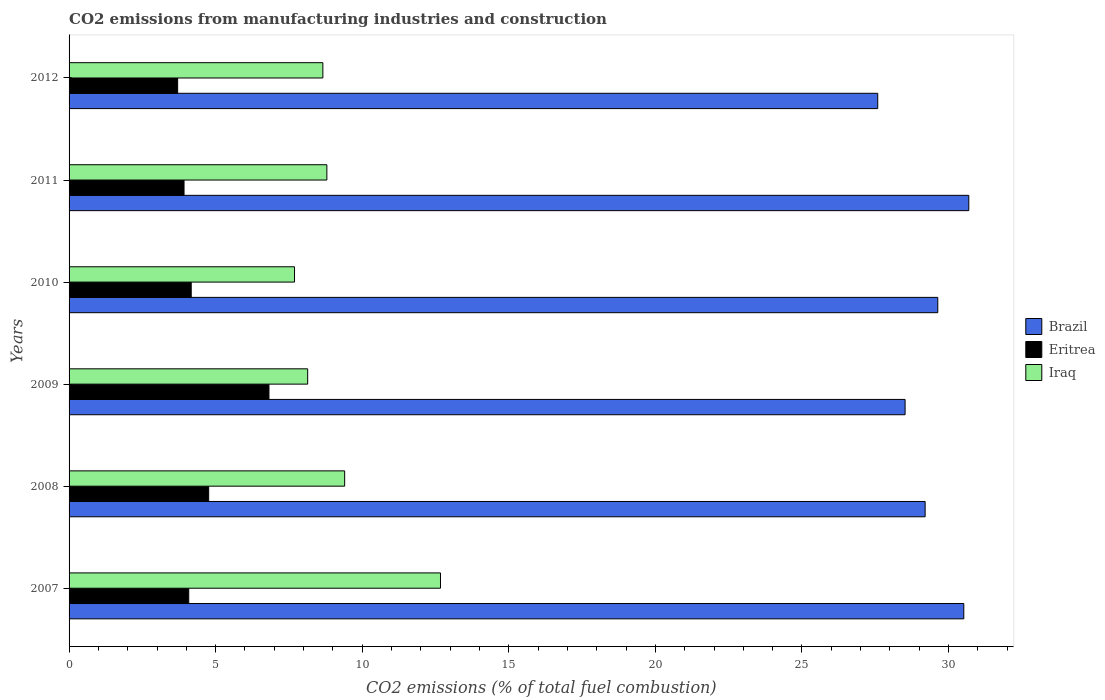Are the number of bars per tick equal to the number of legend labels?
Give a very brief answer. Yes. Are the number of bars on each tick of the Y-axis equal?
Offer a very short reply. Yes. How many bars are there on the 1st tick from the top?
Your answer should be very brief. 3. What is the label of the 2nd group of bars from the top?
Your response must be concise. 2011. In how many cases, is the number of bars for a given year not equal to the number of legend labels?
Your response must be concise. 0. What is the amount of CO2 emitted in Brazil in 2010?
Your response must be concise. 29.63. Across all years, what is the maximum amount of CO2 emitted in Brazil?
Offer a very short reply. 30.69. Across all years, what is the minimum amount of CO2 emitted in Brazil?
Give a very brief answer. 27.58. What is the total amount of CO2 emitted in Brazil in the graph?
Your answer should be compact. 176.15. What is the difference between the amount of CO2 emitted in Iraq in 2010 and that in 2012?
Offer a terse response. -0.97. What is the difference between the amount of CO2 emitted in Brazil in 2010 and the amount of CO2 emitted in Eritrea in 2008?
Provide a succinct answer. 24.87. What is the average amount of CO2 emitted in Eritrea per year?
Make the answer very short. 4.58. In the year 2008, what is the difference between the amount of CO2 emitted in Eritrea and amount of CO2 emitted in Iraq?
Provide a succinct answer. -4.64. What is the ratio of the amount of CO2 emitted in Brazil in 2007 to that in 2012?
Provide a short and direct response. 1.11. Is the amount of CO2 emitted in Eritrea in 2009 less than that in 2011?
Your answer should be compact. No. Is the difference between the amount of CO2 emitted in Eritrea in 2008 and 2012 greater than the difference between the amount of CO2 emitted in Iraq in 2008 and 2012?
Your answer should be compact. Yes. What is the difference between the highest and the second highest amount of CO2 emitted in Eritrea?
Provide a short and direct response. 2.06. What is the difference between the highest and the lowest amount of CO2 emitted in Eritrea?
Ensure brevity in your answer.  3.11. Is the sum of the amount of CO2 emitted in Brazil in 2011 and 2012 greater than the maximum amount of CO2 emitted in Iraq across all years?
Ensure brevity in your answer.  Yes. What does the 2nd bar from the top in 2007 represents?
Your answer should be very brief. Eritrea. What does the 2nd bar from the bottom in 2008 represents?
Offer a terse response. Eritrea. How many bars are there?
Give a very brief answer. 18. Are all the bars in the graph horizontal?
Offer a very short reply. Yes. How many years are there in the graph?
Offer a terse response. 6. What is the difference between two consecutive major ticks on the X-axis?
Give a very brief answer. 5. Does the graph contain any zero values?
Ensure brevity in your answer.  No. How many legend labels are there?
Offer a very short reply. 3. What is the title of the graph?
Offer a very short reply. CO2 emissions from manufacturing industries and construction. Does "Azerbaijan" appear as one of the legend labels in the graph?
Your answer should be compact. No. What is the label or title of the X-axis?
Make the answer very short. CO2 emissions (% of total fuel combustion). What is the CO2 emissions (% of total fuel combustion) in Brazil in 2007?
Your answer should be very brief. 30.52. What is the CO2 emissions (% of total fuel combustion) of Eritrea in 2007?
Your answer should be compact. 4.08. What is the CO2 emissions (% of total fuel combustion) of Iraq in 2007?
Give a very brief answer. 12.67. What is the CO2 emissions (% of total fuel combustion) in Brazil in 2008?
Ensure brevity in your answer.  29.2. What is the CO2 emissions (% of total fuel combustion) of Eritrea in 2008?
Make the answer very short. 4.76. What is the CO2 emissions (% of total fuel combustion) in Iraq in 2008?
Make the answer very short. 9.4. What is the CO2 emissions (% of total fuel combustion) in Brazil in 2009?
Offer a very short reply. 28.52. What is the CO2 emissions (% of total fuel combustion) of Eritrea in 2009?
Keep it short and to the point. 6.82. What is the CO2 emissions (% of total fuel combustion) of Iraq in 2009?
Keep it short and to the point. 8.14. What is the CO2 emissions (% of total fuel combustion) in Brazil in 2010?
Your response must be concise. 29.63. What is the CO2 emissions (% of total fuel combustion) of Eritrea in 2010?
Keep it short and to the point. 4.17. What is the CO2 emissions (% of total fuel combustion) in Iraq in 2010?
Your response must be concise. 7.69. What is the CO2 emissions (% of total fuel combustion) in Brazil in 2011?
Keep it short and to the point. 30.69. What is the CO2 emissions (% of total fuel combustion) in Eritrea in 2011?
Offer a terse response. 3.92. What is the CO2 emissions (% of total fuel combustion) of Iraq in 2011?
Provide a short and direct response. 8.79. What is the CO2 emissions (% of total fuel combustion) of Brazil in 2012?
Offer a terse response. 27.58. What is the CO2 emissions (% of total fuel combustion) in Eritrea in 2012?
Your answer should be very brief. 3.7. What is the CO2 emissions (% of total fuel combustion) of Iraq in 2012?
Give a very brief answer. 8.66. Across all years, what is the maximum CO2 emissions (% of total fuel combustion) in Brazil?
Your answer should be very brief. 30.69. Across all years, what is the maximum CO2 emissions (% of total fuel combustion) of Eritrea?
Provide a short and direct response. 6.82. Across all years, what is the maximum CO2 emissions (% of total fuel combustion) of Iraq?
Your answer should be compact. 12.67. Across all years, what is the minimum CO2 emissions (% of total fuel combustion) in Brazil?
Give a very brief answer. 27.58. Across all years, what is the minimum CO2 emissions (% of total fuel combustion) in Eritrea?
Your answer should be compact. 3.7. Across all years, what is the minimum CO2 emissions (% of total fuel combustion) in Iraq?
Provide a short and direct response. 7.69. What is the total CO2 emissions (% of total fuel combustion) in Brazil in the graph?
Ensure brevity in your answer.  176.15. What is the total CO2 emissions (% of total fuel combustion) of Eritrea in the graph?
Your answer should be compact. 27.45. What is the total CO2 emissions (% of total fuel combustion) in Iraq in the graph?
Your answer should be compact. 55.35. What is the difference between the CO2 emissions (% of total fuel combustion) of Brazil in 2007 and that in 2008?
Keep it short and to the point. 1.32. What is the difference between the CO2 emissions (% of total fuel combustion) in Eritrea in 2007 and that in 2008?
Give a very brief answer. -0.68. What is the difference between the CO2 emissions (% of total fuel combustion) of Iraq in 2007 and that in 2008?
Provide a succinct answer. 3.27. What is the difference between the CO2 emissions (% of total fuel combustion) of Brazil in 2007 and that in 2009?
Your answer should be compact. 2. What is the difference between the CO2 emissions (% of total fuel combustion) in Eritrea in 2007 and that in 2009?
Offer a terse response. -2.74. What is the difference between the CO2 emissions (% of total fuel combustion) in Iraq in 2007 and that in 2009?
Provide a short and direct response. 4.53. What is the difference between the CO2 emissions (% of total fuel combustion) in Brazil in 2007 and that in 2010?
Provide a short and direct response. 0.89. What is the difference between the CO2 emissions (% of total fuel combustion) in Eritrea in 2007 and that in 2010?
Your response must be concise. -0.09. What is the difference between the CO2 emissions (% of total fuel combustion) of Iraq in 2007 and that in 2010?
Your answer should be compact. 4.98. What is the difference between the CO2 emissions (% of total fuel combustion) in Brazil in 2007 and that in 2011?
Offer a very short reply. -0.17. What is the difference between the CO2 emissions (% of total fuel combustion) of Eritrea in 2007 and that in 2011?
Give a very brief answer. 0.16. What is the difference between the CO2 emissions (% of total fuel combustion) in Iraq in 2007 and that in 2011?
Provide a succinct answer. 3.88. What is the difference between the CO2 emissions (% of total fuel combustion) in Brazil in 2007 and that in 2012?
Provide a succinct answer. 2.94. What is the difference between the CO2 emissions (% of total fuel combustion) in Eritrea in 2007 and that in 2012?
Make the answer very short. 0.38. What is the difference between the CO2 emissions (% of total fuel combustion) of Iraq in 2007 and that in 2012?
Keep it short and to the point. 4.01. What is the difference between the CO2 emissions (% of total fuel combustion) in Brazil in 2008 and that in 2009?
Ensure brevity in your answer.  0.68. What is the difference between the CO2 emissions (% of total fuel combustion) of Eritrea in 2008 and that in 2009?
Your answer should be very brief. -2.06. What is the difference between the CO2 emissions (% of total fuel combustion) of Iraq in 2008 and that in 2009?
Ensure brevity in your answer.  1.26. What is the difference between the CO2 emissions (% of total fuel combustion) of Brazil in 2008 and that in 2010?
Provide a succinct answer. -0.43. What is the difference between the CO2 emissions (% of total fuel combustion) in Eritrea in 2008 and that in 2010?
Give a very brief answer. 0.6. What is the difference between the CO2 emissions (% of total fuel combustion) of Iraq in 2008 and that in 2010?
Provide a short and direct response. 1.71. What is the difference between the CO2 emissions (% of total fuel combustion) in Brazil in 2008 and that in 2011?
Offer a very short reply. -1.49. What is the difference between the CO2 emissions (% of total fuel combustion) in Eritrea in 2008 and that in 2011?
Provide a succinct answer. 0.84. What is the difference between the CO2 emissions (% of total fuel combustion) of Iraq in 2008 and that in 2011?
Provide a short and direct response. 0.61. What is the difference between the CO2 emissions (% of total fuel combustion) in Brazil in 2008 and that in 2012?
Keep it short and to the point. 1.62. What is the difference between the CO2 emissions (% of total fuel combustion) of Eritrea in 2008 and that in 2012?
Your answer should be very brief. 1.06. What is the difference between the CO2 emissions (% of total fuel combustion) in Iraq in 2008 and that in 2012?
Make the answer very short. 0.74. What is the difference between the CO2 emissions (% of total fuel combustion) in Brazil in 2009 and that in 2010?
Your response must be concise. -1.11. What is the difference between the CO2 emissions (% of total fuel combustion) of Eritrea in 2009 and that in 2010?
Make the answer very short. 2.65. What is the difference between the CO2 emissions (% of total fuel combustion) in Iraq in 2009 and that in 2010?
Your answer should be compact. 0.45. What is the difference between the CO2 emissions (% of total fuel combustion) of Brazil in 2009 and that in 2011?
Provide a succinct answer. -2.17. What is the difference between the CO2 emissions (% of total fuel combustion) of Eritrea in 2009 and that in 2011?
Provide a succinct answer. 2.9. What is the difference between the CO2 emissions (% of total fuel combustion) of Iraq in 2009 and that in 2011?
Your response must be concise. -0.65. What is the difference between the CO2 emissions (% of total fuel combustion) in Brazil in 2009 and that in 2012?
Provide a succinct answer. 0.93. What is the difference between the CO2 emissions (% of total fuel combustion) in Eritrea in 2009 and that in 2012?
Your answer should be very brief. 3.11. What is the difference between the CO2 emissions (% of total fuel combustion) of Iraq in 2009 and that in 2012?
Your answer should be compact. -0.52. What is the difference between the CO2 emissions (% of total fuel combustion) in Brazil in 2010 and that in 2011?
Provide a short and direct response. -1.06. What is the difference between the CO2 emissions (% of total fuel combustion) of Eritrea in 2010 and that in 2011?
Ensure brevity in your answer.  0.25. What is the difference between the CO2 emissions (% of total fuel combustion) in Iraq in 2010 and that in 2011?
Your response must be concise. -1.1. What is the difference between the CO2 emissions (% of total fuel combustion) in Brazil in 2010 and that in 2012?
Provide a succinct answer. 2.05. What is the difference between the CO2 emissions (% of total fuel combustion) in Eritrea in 2010 and that in 2012?
Your answer should be compact. 0.46. What is the difference between the CO2 emissions (% of total fuel combustion) of Iraq in 2010 and that in 2012?
Provide a short and direct response. -0.97. What is the difference between the CO2 emissions (% of total fuel combustion) of Brazil in 2011 and that in 2012?
Offer a very short reply. 3.11. What is the difference between the CO2 emissions (% of total fuel combustion) in Eritrea in 2011 and that in 2012?
Your answer should be compact. 0.22. What is the difference between the CO2 emissions (% of total fuel combustion) in Iraq in 2011 and that in 2012?
Your answer should be compact. 0.14. What is the difference between the CO2 emissions (% of total fuel combustion) of Brazil in 2007 and the CO2 emissions (% of total fuel combustion) of Eritrea in 2008?
Make the answer very short. 25.76. What is the difference between the CO2 emissions (% of total fuel combustion) in Brazil in 2007 and the CO2 emissions (% of total fuel combustion) in Iraq in 2008?
Offer a terse response. 21.12. What is the difference between the CO2 emissions (% of total fuel combustion) of Eritrea in 2007 and the CO2 emissions (% of total fuel combustion) of Iraq in 2008?
Offer a terse response. -5.32. What is the difference between the CO2 emissions (% of total fuel combustion) in Brazil in 2007 and the CO2 emissions (% of total fuel combustion) in Eritrea in 2009?
Offer a very short reply. 23.7. What is the difference between the CO2 emissions (% of total fuel combustion) of Brazil in 2007 and the CO2 emissions (% of total fuel combustion) of Iraq in 2009?
Provide a short and direct response. 22.38. What is the difference between the CO2 emissions (% of total fuel combustion) of Eritrea in 2007 and the CO2 emissions (% of total fuel combustion) of Iraq in 2009?
Provide a short and direct response. -4.06. What is the difference between the CO2 emissions (% of total fuel combustion) in Brazil in 2007 and the CO2 emissions (% of total fuel combustion) in Eritrea in 2010?
Offer a terse response. 26.35. What is the difference between the CO2 emissions (% of total fuel combustion) in Brazil in 2007 and the CO2 emissions (% of total fuel combustion) in Iraq in 2010?
Give a very brief answer. 22.83. What is the difference between the CO2 emissions (% of total fuel combustion) in Eritrea in 2007 and the CO2 emissions (% of total fuel combustion) in Iraq in 2010?
Your answer should be very brief. -3.61. What is the difference between the CO2 emissions (% of total fuel combustion) of Brazil in 2007 and the CO2 emissions (% of total fuel combustion) of Eritrea in 2011?
Keep it short and to the point. 26.6. What is the difference between the CO2 emissions (% of total fuel combustion) in Brazil in 2007 and the CO2 emissions (% of total fuel combustion) in Iraq in 2011?
Give a very brief answer. 21.73. What is the difference between the CO2 emissions (% of total fuel combustion) of Eritrea in 2007 and the CO2 emissions (% of total fuel combustion) of Iraq in 2011?
Offer a terse response. -4.71. What is the difference between the CO2 emissions (% of total fuel combustion) in Brazil in 2007 and the CO2 emissions (% of total fuel combustion) in Eritrea in 2012?
Provide a succinct answer. 26.82. What is the difference between the CO2 emissions (% of total fuel combustion) in Brazil in 2007 and the CO2 emissions (% of total fuel combustion) in Iraq in 2012?
Offer a very short reply. 21.86. What is the difference between the CO2 emissions (% of total fuel combustion) of Eritrea in 2007 and the CO2 emissions (% of total fuel combustion) of Iraq in 2012?
Offer a terse response. -4.58. What is the difference between the CO2 emissions (% of total fuel combustion) of Brazil in 2008 and the CO2 emissions (% of total fuel combustion) of Eritrea in 2009?
Provide a succinct answer. 22.38. What is the difference between the CO2 emissions (% of total fuel combustion) in Brazil in 2008 and the CO2 emissions (% of total fuel combustion) in Iraq in 2009?
Your response must be concise. 21.06. What is the difference between the CO2 emissions (% of total fuel combustion) in Eritrea in 2008 and the CO2 emissions (% of total fuel combustion) in Iraq in 2009?
Offer a terse response. -3.38. What is the difference between the CO2 emissions (% of total fuel combustion) in Brazil in 2008 and the CO2 emissions (% of total fuel combustion) in Eritrea in 2010?
Give a very brief answer. 25.04. What is the difference between the CO2 emissions (% of total fuel combustion) in Brazil in 2008 and the CO2 emissions (% of total fuel combustion) in Iraq in 2010?
Provide a succinct answer. 21.51. What is the difference between the CO2 emissions (% of total fuel combustion) in Eritrea in 2008 and the CO2 emissions (% of total fuel combustion) in Iraq in 2010?
Offer a very short reply. -2.93. What is the difference between the CO2 emissions (% of total fuel combustion) in Brazil in 2008 and the CO2 emissions (% of total fuel combustion) in Eritrea in 2011?
Your answer should be very brief. 25.28. What is the difference between the CO2 emissions (% of total fuel combustion) in Brazil in 2008 and the CO2 emissions (% of total fuel combustion) in Iraq in 2011?
Your answer should be very brief. 20.41. What is the difference between the CO2 emissions (% of total fuel combustion) in Eritrea in 2008 and the CO2 emissions (% of total fuel combustion) in Iraq in 2011?
Your answer should be very brief. -4.03. What is the difference between the CO2 emissions (% of total fuel combustion) in Brazil in 2008 and the CO2 emissions (% of total fuel combustion) in Eritrea in 2012?
Ensure brevity in your answer.  25.5. What is the difference between the CO2 emissions (% of total fuel combustion) of Brazil in 2008 and the CO2 emissions (% of total fuel combustion) of Iraq in 2012?
Your answer should be compact. 20.54. What is the difference between the CO2 emissions (% of total fuel combustion) in Eritrea in 2008 and the CO2 emissions (% of total fuel combustion) in Iraq in 2012?
Provide a short and direct response. -3.9. What is the difference between the CO2 emissions (% of total fuel combustion) in Brazil in 2009 and the CO2 emissions (% of total fuel combustion) in Eritrea in 2010?
Your answer should be compact. 24.35. What is the difference between the CO2 emissions (% of total fuel combustion) in Brazil in 2009 and the CO2 emissions (% of total fuel combustion) in Iraq in 2010?
Offer a terse response. 20.83. What is the difference between the CO2 emissions (% of total fuel combustion) of Eritrea in 2009 and the CO2 emissions (% of total fuel combustion) of Iraq in 2010?
Your answer should be very brief. -0.87. What is the difference between the CO2 emissions (% of total fuel combustion) of Brazil in 2009 and the CO2 emissions (% of total fuel combustion) of Eritrea in 2011?
Provide a short and direct response. 24.6. What is the difference between the CO2 emissions (% of total fuel combustion) of Brazil in 2009 and the CO2 emissions (% of total fuel combustion) of Iraq in 2011?
Offer a terse response. 19.72. What is the difference between the CO2 emissions (% of total fuel combustion) of Eritrea in 2009 and the CO2 emissions (% of total fuel combustion) of Iraq in 2011?
Provide a succinct answer. -1.98. What is the difference between the CO2 emissions (% of total fuel combustion) in Brazil in 2009 and the CO2 emissions (% of total fuel combustion) in Eritrea in 2012?
Offer a very short reply. 24.81. What is the difference between the CO2 emissions (% of total fuel combustion) of Brazil in 2009 and the CO2 emissions (% of total fuel combustion) of Iraq in 2012?
Offer a terse response. 19.86. What is the difference between the CO2 emissions (% of total fuel combustion) in Eritrea in 2009 and the CO2 emissions (% of total fuel combustion) in Iraq in 2012?
Make the answer very short. -1.84. What is the difference between the CO2 emissions (% of total fuel combustion) of Brazil in 2010 and the CO2 emissions (% of total fuel combustion) of Eritrea in 2011?
Your response must be concise. 25.71. What is the difference between the CO2 emissions (% of total fuel combustion) in Brazil in 2010 and the CO2 emissions (% of total fuel combustion) in Iraq in 2011?
Ensure brevity in your answer.  20.84. What is the difference between the CO2 emissions (% of total fuel combustion) in Eritrea in 2010 and the CO2 emissions (% of total fuel combustion) in Iraq in 2011?
Offer a terse response. -4.63. What is the difference between the CO2 emissions (% of total fuel combustion) in Brazil in 2010 and the CO2 emissions (% of total fuel combustion) in Eritrea in 2012?
Your response must be concise. 25.93. What is the difference between the CO2 emissions (% of total fuel combustion) in Brazil in 2010 and the CO2 emissions (% of total fuel combustion) in Iraq in 2012?
Provide a short and direct response. 20.98. What is the difference between the CO2 emissions (% of total fuel combustion) in Eritrea in 2010 and the CO2 emissions (% of total fuel combustion) in Iraq in 2012?
Keep it short and to the point. -4.49. What is the difference between the CO2 emissions (% of total fuel combustion) of Brazil in 2011 and the CO2 emissions (% of total fuel combustion) of Eritrea in 2012?
Your response must be concise. 26.99. What is the difference between the CO2 emissions (% of total fuel combustion) in Brazil in 2011 and the CO2 emissions (% of total fuel combustion) in Iraq in 2012?
Give a very brief answer. 22.03. What is the difference between the CO2 emissions (% of total fuel combustion) of Eritrea in 2011 and the CO2 emissions (% of total fuel combustion) of Iraq in 2012?
Offer a very short reply. -4.74. What is the average CO2 emissions (% of total fuel combustion) of Brazil per year?
Keep it short and to the point. 29.36. What is the average CO2 emissions (% of total fuel combustion) of Eritrea per year?
Give a very brief answer. 4.58. What is the average CO2 emissions (% of total fuel combustion) of Iraq per year?
Offer a very short reply. 9.22. In the year 2007, what is the difference between the CO2 emissions (% of total fuel combustion) of Brazil and CO2 emissions (% of total fuel combustion) of Eritrea?
Make the answer very short. 26.44. In the year 2007, what is the difference between the CO2 emissions (% of total fuel combustion) of Brazil and CO2 emissions (% of total fuel combustion) of Iraq?
Offer a terse response. 17.85. In the year 2007, what is the difference between the CO2 emissions (% of total fuel combustion) of Eritrea and CO2 emissions (% of total fuel combustion) of Iraq?
Your answer should be compact. -8.59. In the year 2008, what is the difference between the CO2 emissions (% of total fuel combustion) in Brazil and CO2 emissions (% of total fuel combustion) in Eritrea?
Ensure brevity in your answer.  24.44. In the year 2008, what is the difference between the CO2 emissions (% of total fuel combustion) in Brazil and CO2 emissions (% of total fuel combustion) in Iraq?
Your response must be concise. 19.8. In the year 2008, what is the difference between the CO2 emissions (% of total fuel combustion) of Eritrea and CO2 emissions (% of total fuel combustion) of Iraq?
Provide a short and direct response. -4.64. In the year 2009, what is the difference between the CO2 emissions (% of total fuel combustion) of Brazil and CO2 emissions (% of total fuel combustion) of Eritrea?
Ensure brevity in your answer.  21.7. In the year 2009, what is the difference between the CO2 emissions (% of total fuel combustion) of Brazil and CO2 emissions (% of total fuel combustion) of Iraq?
Provide a succinct answer. 20.38. In the year 2009, what is the difference between the CO2 emissions (% of total fuel combustion) of Eritrea and CO2 emissions (% of total fuel combustion) of Iraq?
Give a very brief answer. -1.32. In the year 2010, what is the difference between the CO2 emissions (% of total fuel combustion) of Brazil and CO2 emissions (% of total fuel combustion) of Eritrea?
Offer a terse response. 25.47. In the year 2010, what is the difference between the CO2 emissions (% of total fuel combustion) in Brazil and CO2 emissions (% of total fuel combustion) in Iraq?
Give a very brief answer. 21.94. In the year 2010, what is the difference between the CO2 emissions (% of total fuel combustion) in Eritrea and CO2 emissions (% of total fuel combustion) in Iraq?
Provide a short and direct response. -3.52. In the year 2011, what is the difference between the CO2 emissions (% of total fuel combustion) of Brazil and CO2 emissions (% of total fuel combustion) of Eritrea?
Your answer should be very brief. 26.77. In the year 2011, what is the difference between the CO2 emissions (% of total fuel combustion) in Brazil and CO2 emissions (% of total fuel combustion) in Iraq?
Make the answer very short. 21.9. In the year 2011, what is the difference between the CO2 emissions (% of total fuel combustion) in Eritrea and CO2 emissions (% of total fuel combustion) in Iraq?
Offer a very short reply. -4.87. In the year 2012, what is the difference between the CO2 emissions (% of total fuel combustion) in Brazil and CO2 emissions (% of total fuel combustion) in Eritrea?
Offer a terse response. 23.88. In the year 2012, what is the difference between the CO2 emissions (% of total fuel combustion) in Brazil and CO2 emissions (% of total fuel combustion) in Iraq?
Provide a succinct answer. 18.93. In the year 2012, what is the difference between the CO2 emissions (% of total fuel combustion) of Eritrea and CO2 emissions (% of total fuel combustion) of Iraq?
Provide a short and direct response. -4.95. What is the ratio of the CO2 emissions (% of total fuel combustion) in Brazil in 2007 to that in 2008?
Provide a short and direct response. 1.05. What is the ratio of the CO2 emissions (% of total fuel combustion) of Eritrea in 2007 to that in 2008?
Your answer should be very brief. 0.86. What is the ratio of the CO2 emissions (% of total fuel combustion) of Iraq in 2007 to that in 2008?
Your answer should be very brief. 1.35. What is the ratio of the CO2 emissions (% of total fuel combustion) of Brazil in 2007 to that in 2009?
Keep it short and to the point. 1.07. What is the ratio of the CO2 emissions (% of total fuel combustion) of Eritrea in 2007 to that in 2009?
Offer a terse response. 0.6. What is the ratio of the CO2 emissions (% of total fuel combustion) of Iraq in 2007 to that in 2009?
Your answer should be very brief. 1.56. What is the ratio of the CO2 emissions (% of total fuel combustion) of Brazil in 2007 to that in 2010?
Your answer should be compact. 1.03. What is the ratio of the CO2 emissions (% of total fuel combustion) of Eritrea in 2007 to that in 2010?
Make the answer very short. 0.98. What is the ratio of the CO2 emissions (% of total fuel combustion) in Iraq in 2007 to that in 2010?
Give a very brief answer. 1.65. What is the ratio of the CO2 emissions (% of total fuel combustion) of Brazil in 2007 to that in 2011?
Your response must be concise. 0.99. What is the ratio of the CO2 emissions (% of total fuel combustion) of Eritrea in 2007 to that in 2011?
Make the answer very short. 1.04. What is the ratio of the CO2 emissions (% of total fuel combustion) in Iraq in 2007 to that in 2011?
Your answer should be very brief. 1.44. What is the ratio of the CO2 emissions (% of total fuel combustion) of Brazil in 2007 to that in 2012?
Your response must be concise. 1.11. What is the ratio of the CO2 emissions (% of total fuel combustion) of Eritrea in 2007 to that in 2012?
Offer a terse response. 1.1. What is the ratio of the CO2 emissions (% of total fuel combustion) of Iraq in 2007 to that in 2012?
Ensure brevity in your answer.  1.46. What is the ratio of the CO2 emissions (% of total fuel combustion) in Brazil in 2008 to that in 2009?
Your response must be concise. 1.02. What is the ratio of the CO2 emissions (% of total fuel combustion) of Eritrea in 2008 to that in 2009?
Your answer should be compact. 0.7. What is the ratio of the CO2 emissions (% of total fuel combustion) of Iraq in 2008 to that in 2009?
Your response must be concise. 1.16. What is the ratio of the CO2 emissions (% of total fuel combustion) of Brazil in 2008 to that in 2010?
Provide a short and direct response. 0.99. What is the ratio of the CO2 emissions (% of total fuel combustion) of Eritrea in 2008 to that in 2010?
Offer a terse response. 1.14. What is the ratio of the CO2 emissions (% of total fuel combustion) in Iraq in 2008 to that in 2010?
Make the answer very short. 1.22. What is the ratio of the CO2 emissions (% of total fuel combustion) in Brazil in 2008 to that in 2011?
Give a very brief answer. 0.95. What is the ratio of the CO2 emissions (% of total fuel combustion) of Eritrea in 2008 to that in 2011?
Keep it short and to the point. 1.21. What is the ratio of the CO2 emissions (% of total fuel combustion) in Iraq in 2008 to that in 2011?
Offer a very short reply. 1.07. What is the ratio of the CO2 emissions (% of total fuel combustion) in Brazil in 2008 to that in 2012?
Keep it short and to the point. 1.06. What is the ratio of the CO2 emissions (% of total fuel combustion) in Iraq in 2008 to that in 2012?
Keep it short and to the point. 1.09. What is the ratio of the CO2 emissions (% of total fuel combustion) of Brazil in 2009 to that in 2010?
Provide a succinct answer. 0.96. What is the ratio of the CO2 emissions (% of total fuel combustion) in Eritrea in 2009 to that in 2010?
Offer a terse response. 1.64. What is the ratio of the CO2 emissions (% of total fuel combustion) of Iraq in 2009 to that in 2010?
Keep it short and to the point. 1.06. What is the ratio of the CO2 emissions (% of total fuel combustion) of Brazil in 2009 to that in 2011?
Provide a succinct answer. 0.93. What is the ratio of the CO2 emissions (% of total fuel combustion) of Eritrea in 2009 to that in 2011?
Ensure brevity in your answer.  1.74. What is the ratio of the CO2 emissions (% of total fuel combustion) in Iraq in 2009 to that in 2011?
Offer a very short reply. 0.93. What is the ratio of the CO2 emissions (% of total fuel combustion) in Brazil in 2009 to that in 2012?
Provide a succinct answer. 1.03. What is the ratio of the CO2 emissions (% of total fuel combustion) of Eritrea in 2009 to that in 2012?
Your response must be concise. 1.84. What is the ratio of the CO2 emissions (% of total fuel combustion) of Iraq in 2009 to that in 2012?
Provide a short and direct response. 0.94. What is the ratio of the CO2 emissions (% of total fuel combustion) in Brazil in 2010 to that in 2011?
Offer a very short reply. 0.97. What is the ratio of the CO2 emissions (% of total fuel combustion) of Iraq in 2010 to that in 2011?
Your answer should be compact. 0.87. What is the ratio of the CO2 emissions (% of total fuel combustion) in Brazil in 2010 to that in 2012?
Ensure brevity in your answer.  1.07. What is the ratio of the CO2 emissions (% of total fuel combustion) in Iraq in 2010 to that in 2012?
Offer a very short reply. 0.89. What is the ratio of the CO2 emissions (% of total fuel combustion) in Brazil in 2011 to that in 2012?
Your answer should be compact. 1.11. What is the ratio of the CO2 emissions (% of total fuel combustion) in Eritrea in 2011 to that in 2012?
Your answer should be very brief. 1.06. What is the ratio of the CO2 emissions (% of total fuel combustion) of Iraq in 2011 to that in 2012?
Provide a succinct answer. 1.02. What is the difference between the highest and the second highest CO2 emissions (% of total fuel combustion) in Brazil?
Provide a succinct answer. 0.17. What is the difference between the highest and the second highest CO2 emissions (% of total fuel combustion) in Eritrea?
Your answer should be very brief. 2.06. What is the difference between the highest and the second highest CO2 emissions (% of total fuel combustion) of Iraq?
Your answer should be compact. 3.27. What is the difference between the highest and the lowest CO2 emissions (% of total fuel combustion) of Brazil?
Keep it short and to the point. 3.11. What is the difference between the highest and the lowest CO2 emissions (% of total fuel combustion) in Eritrea?
Your answer should be compact. 3.11. What is the difference between the highest and the lowest CO2 emissions (% of total fuel combustion) in Iraq?
Offer a terse response. 4.98. 